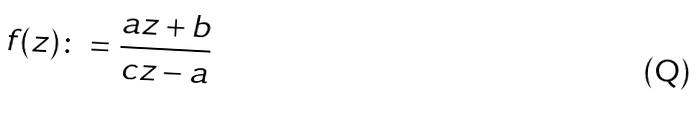<formula> <loc_0><loc_0><loc_500><loc_500>f ( z ) \colon = \frac { a z + b } { c z - a }</formula> 